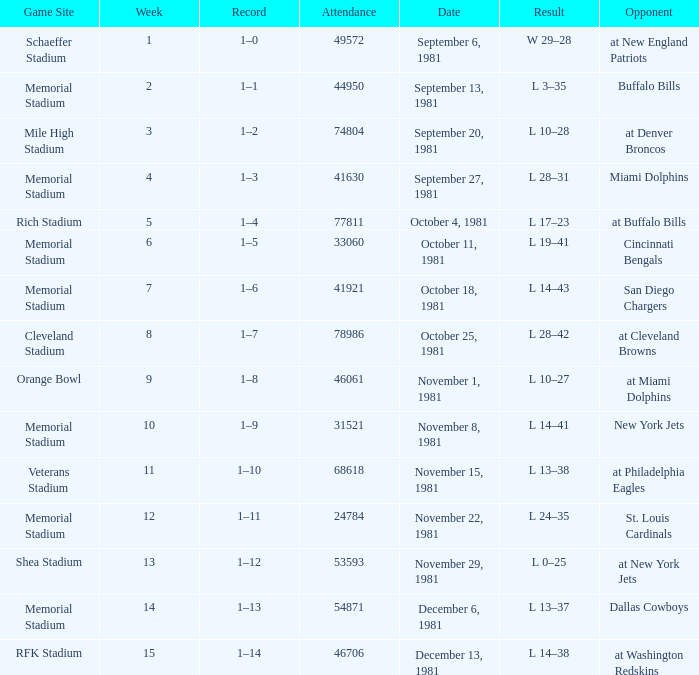When it is week 2 what is the record? 1–1. 